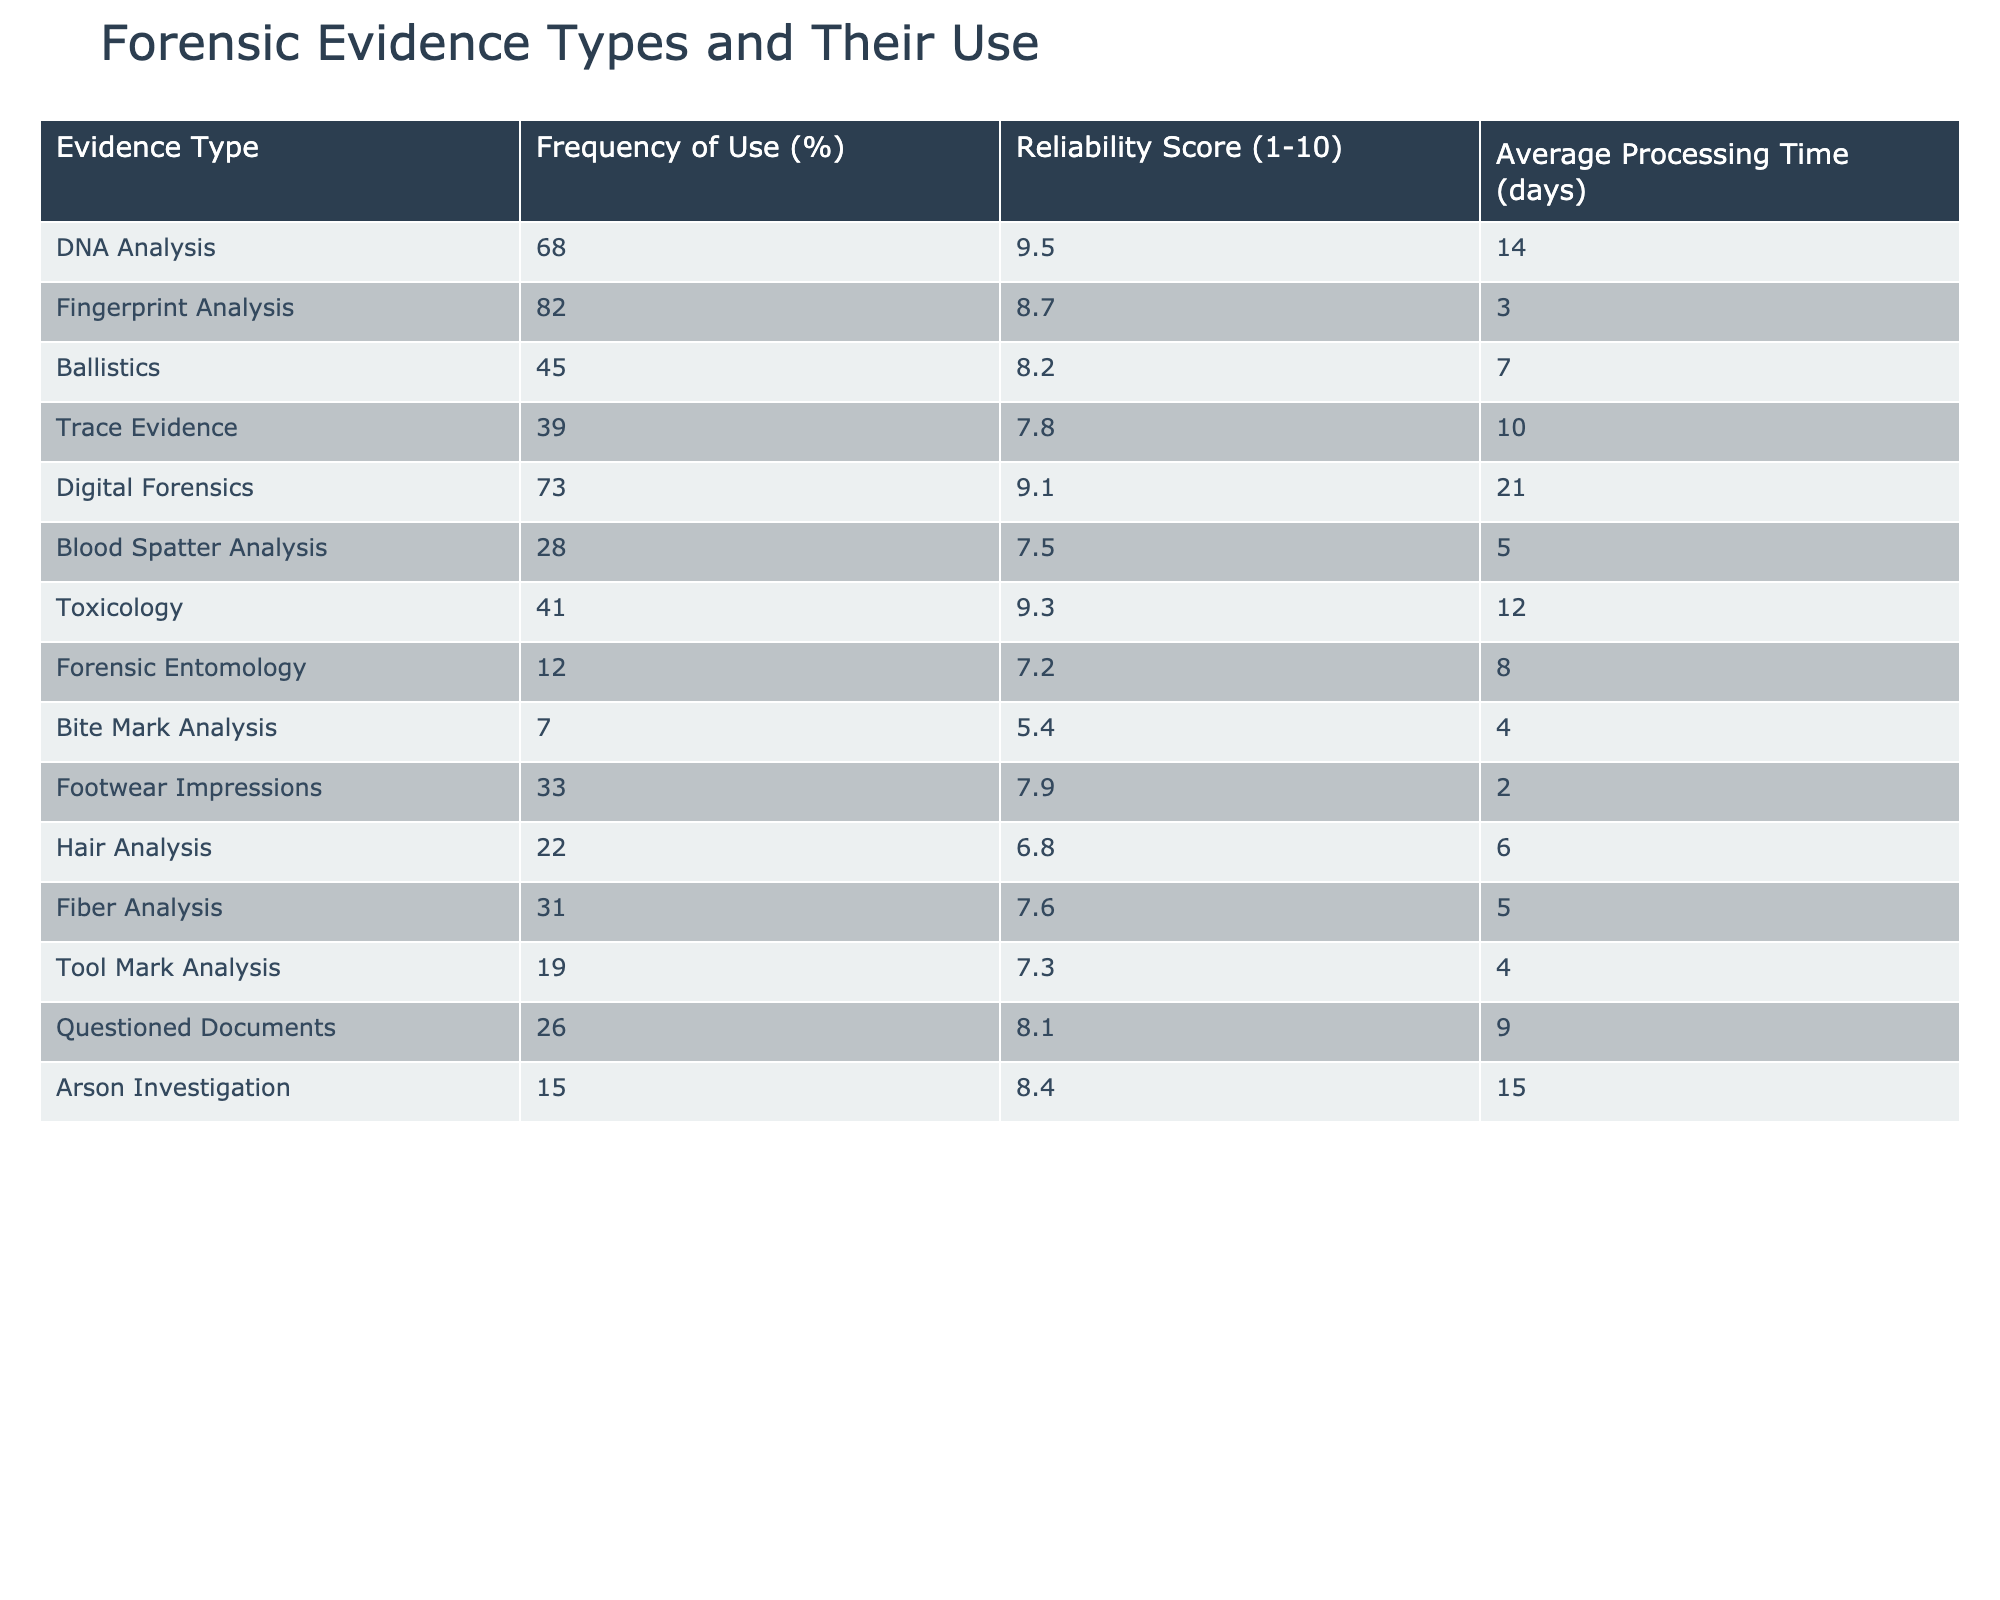What percentage of crime cases use DNA Analysis? The table shows that DNA Analysis has a Frequency of Use of 68%.
Answer: 68% Which forensic evidence type has the highest reliability score? By comparing the Reliability Scores in the table, Fingerprint Analysis has the highest score of 8.7.
Answer: Fingerprint Analysis How many days does it typically take to process Digital Forensics? The Average Processing Time for Digital Forensics in the table is 21 days.
Answer: 21 days What is the difference in frequency between Fingerprint Analysis and Blood Spatter Analysis? Fingerprint Analysis has a frequency of 82% and Blood Spatter Analysis has 28%, so the difference is 82 - 28 = 54%.
Answer: 54% Is it true that Bite Mark Analysis has a reliability score higher than 6? The reliability score for Bite Mark Analysis is 5.4, which is not higher than 6, so the statement is false.
Answer: False Which two evidence types have a frequency of use below 30%? By examining the table, Bite Mark Analysis (7%) and Forensic Entomology (12%) are the only two with a frequency below 30%.
Answer: Bite Mark Analysis and Forensic Entomology What is the average processing time for all evidence types listed? To find the average processing time, sum all processing times (14 + 3 + 7 + 10 + 21 + 5 + 12 + 8 + 4 + 2 + 6 + 5 + 4 + 15) =  112 days. There are 14 evidence types, so average is 112/14 = 8 days.
Answer: 8 days Which evidence type is processed the fastest? Footwear Impressions has the lowest processing time of 2 days among all evidence types.
Answer: Footwear Impressions How many more days does it take to process Toxicology compared to Trace Evidence? Toxicology takes 12 days and Trace Evidence takes 10 days, so the difference is 12 - 10 = 2 days longer for Toxicology.
Answer: 2 days Which evidence type with a reliability score below 8 has the highest frequency of use? Looking at the table, Trace Evidence (39%) has the highest frequency below a reliability score of 8 since it scores 7.8.
Answer: Trace Evidence 